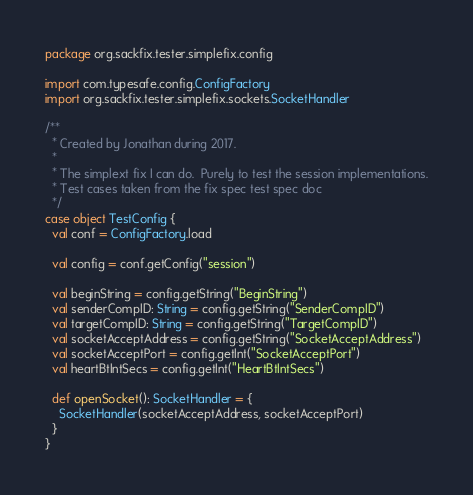<code> <loc_0><loc_0><loc_500><loc_500><_Scala_>package org.sackfix.tester.simplefix.config

import com.typesafe.config.ConfigFactory
import org.sackfix.tester.simplefix.sockets.SocketHandler

/**
  * Created by Jonathan during 2017.
  *
  * The simplext fix I can do.  Purely to test the session implementations.
  * Test cases taken from the fix spec test spec doc
  */
case object TestConfig {
  val conf = ConfigFactory.load

  val config = conf.getConfig("session")

  val beginString = config.getString("BeginString")
  val senderCompID: String = config.getString("SenderCompID")
  val targetCompID: String = config.getString("TargetCompID")
  val socketAcceptAddress = config.getString("SocketAcceptAddress")
  val socketAcceptPort = config.getInt("SocketAcceptPort")
  val heartBtIntSecs = config.getInt("HeartBtIntSecs")

  def openSocket(): SocketHandler = {
    SocketHandler(socketAcceptAddress, socketAcceptPort)
  }
}
</code> 